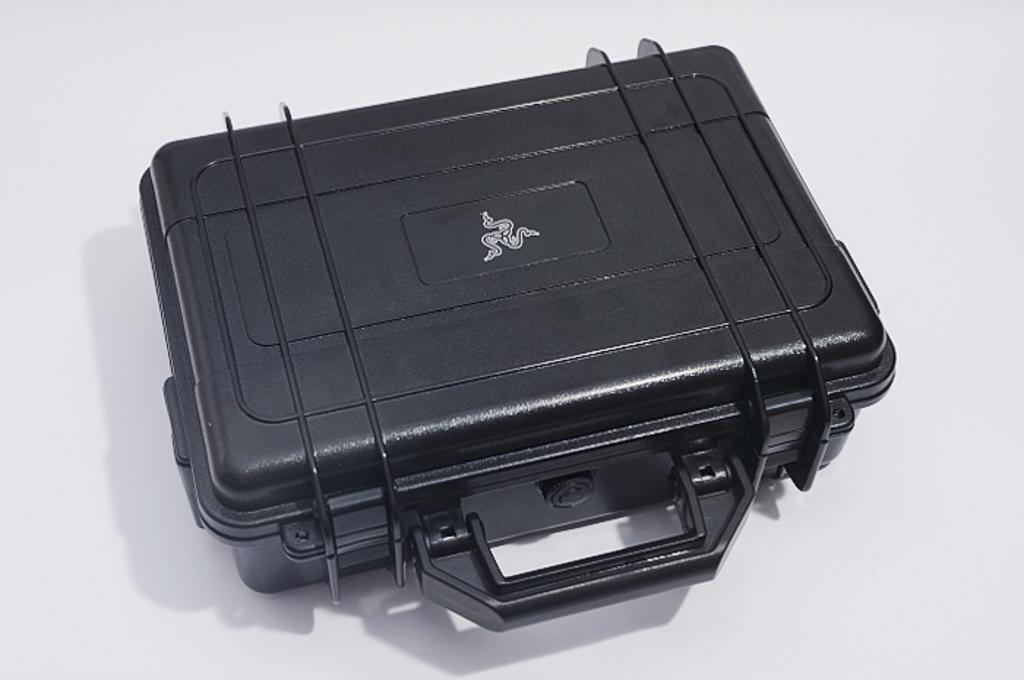How would you summarize this image in a sentence or two? In this picture i can see a white color background on the image. And i can see a black color suitcase and there is a symbol the suitcase and that is in white color 